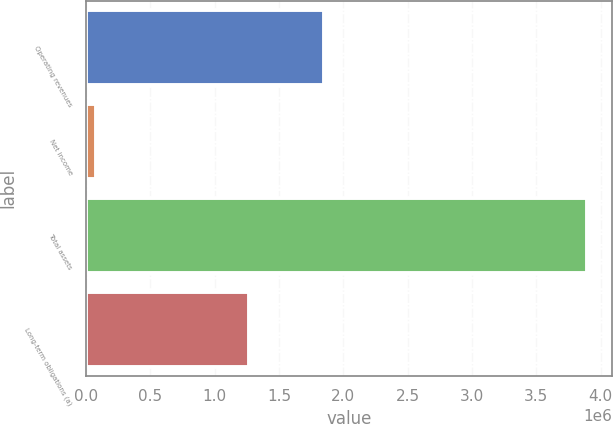<chart> <loc_0><loc_0><loc_500><loc_500><bar_chart><fcel>Operating revenues<fcel>Net income<fcel>Total assets<fcel>Long-term obligations (a)<nl><fcel>1.85198e+06<fcel>74804<fcel>3.89799e+06<fcel>1.26884e+06<nl></chart> 